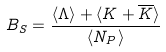<formula> <loc_0><loc_0><loc_500><loc_500>B _ { S } = \frac { \langle \Lambda \rangle + \langle K + \overline { K } \rangle } { \langle N _ { P } \rangle }</formula> 